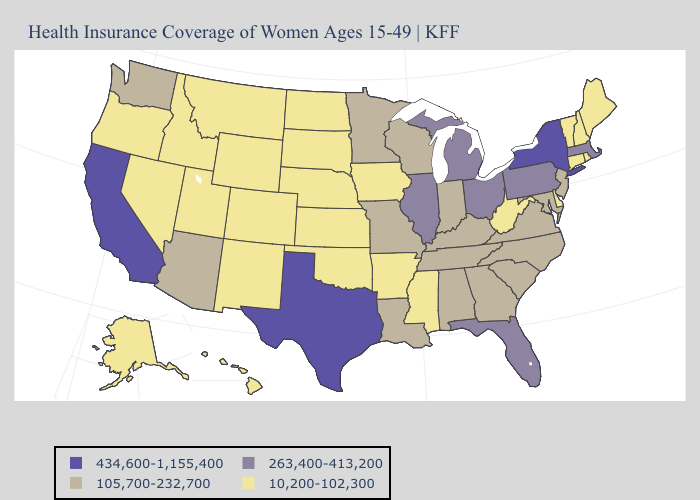What is the value of Ohio?
Concise answer only. 263,400-413,200. Name the states that have a value in the range 434,600-1,155,400?
Quick response, please. California, New York, Texas. Name the states that have a value in the range 10,200-102,300?
Answer briefly. Alaska, Arkansas, Colorado, Connecticut, Delaware, Hawaii, Idaho, Iowa, Kansas, Maine, Mississippi, Montana, Nebraska, Nevada, New Hampshire, New Mexico, North Dakota, Oklahoma, Oregon, Rhode Island, South Dakota, Utah, Vermont, West Virginia, Wyoming. Does New York have the highest value in the Northeast?
Quick response, please. Yes. Does Nevada have the lowest value in the West?
Short answer required. Yes. How many symbols are there in the legend?
Quick response, please. 4. Does Mississippi have the same value as Arizona?
Quick response, please. No. Which states have the highest value in the USA?
Keep it brief. California, New York, Texas. What is the value of North Dakota?
Keep it brief. 10,200-102,300. What is the highest value in states that border Texas?
Write a very short answer. 105,700-232,700. What is the highest value in the South ?
Short answer required. 434,600-1,155,400. Does Missouri have the lowest value in the USA?
Be succinct. No. How many symbols are there in the legend?
Keep it brief. 4. What is the lowest value in the USA?
Give a very brief answer. 10,200-102,300. What is the value of Illinois?
Short answer required. 263,400-413,200. 